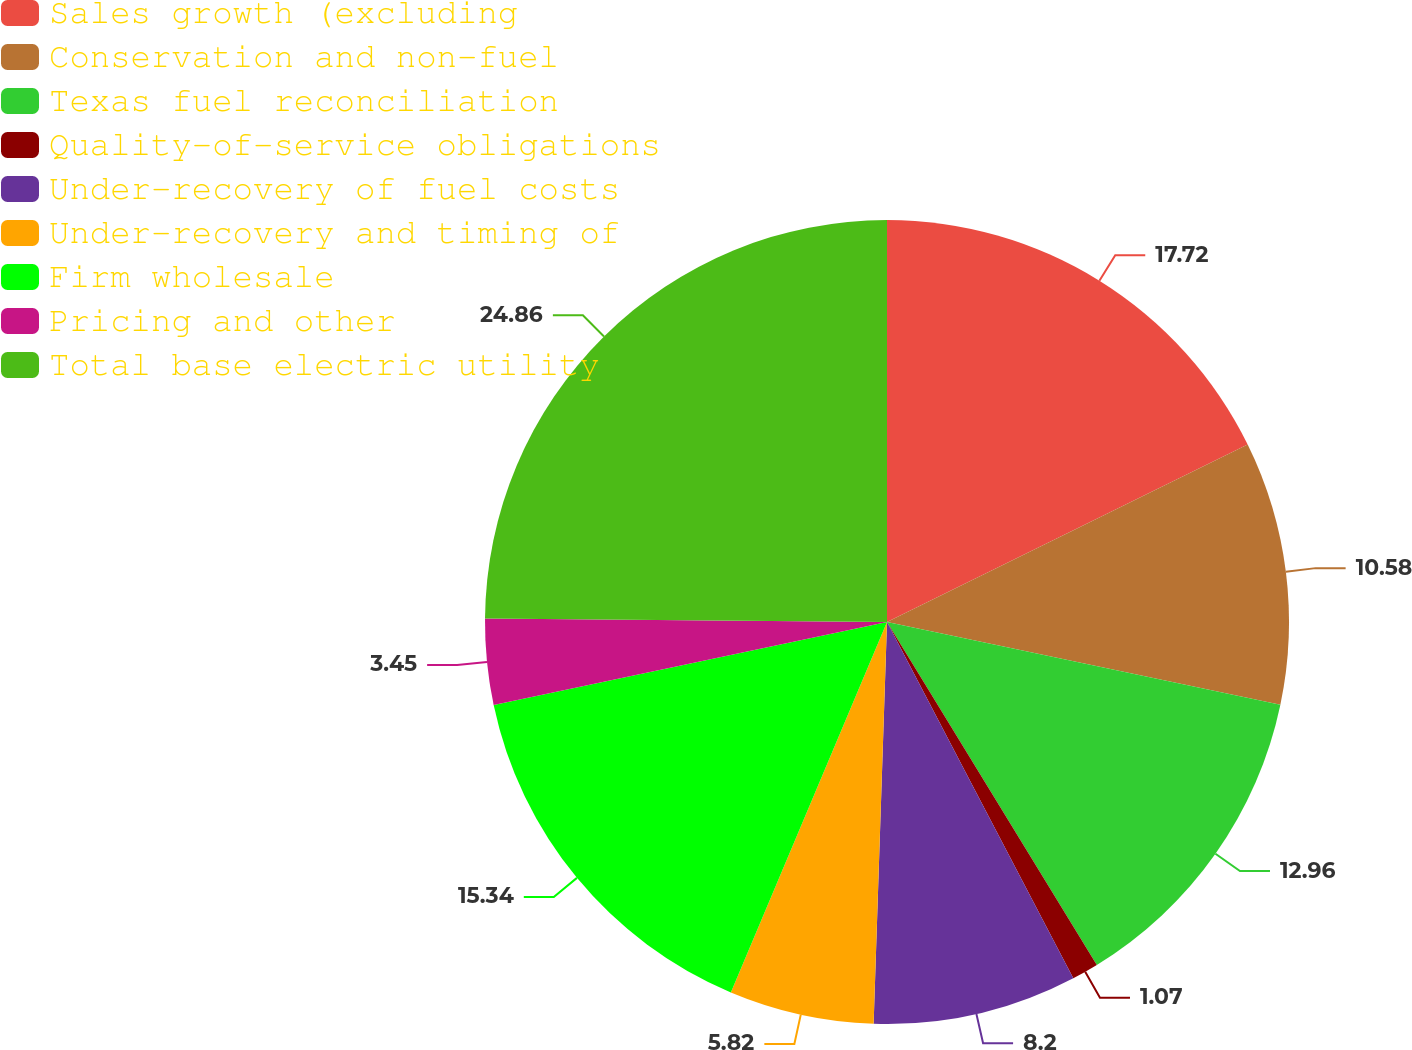Convert chart to OTSL. <chart><loc_0><loc_0><loc_500><loc_500><pie_chart><fcel>Sales growth (excluding<fcel>Conservation and non-fuel<fcel>Texas fuel reconciliation<fcel>Quality-of-service obligations<fcel>Under-recovery of fuel costs<fcel>Under-recovery and timing of<fcel>Firm wholesale<fcel>Pricing and other<fcel>Total base electric utility<nl><fcel>17.72%<fcel>10.58%<fcel>12.96%<fcel>1.07%<fcel>8.2%<fcel>5.82%<fcel>15.34%<fcel>3.45%<fcel>24.86%<nl></chart> 